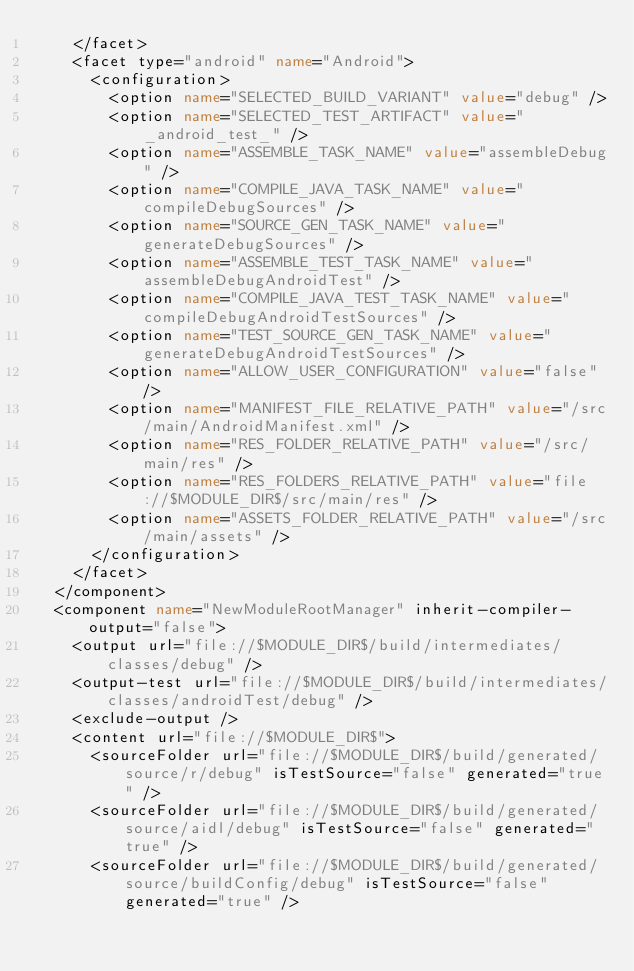<code> <loc_0><loc_0><loc_500><loc_500><_XML_>    </facet>
    <facet type="android" name="Android">
      <configuration>
        <option name="SELECTED_BUILD_VARIANT" value="debug" />
        <option name="SELECTED_TEST_ARTIFACT" value="_android_test_" />
        <option name="ASSEMBLE_TASK_NAME" value="assembleDebug" />
        <option name="COMPILE_JAVA_TASK_NAME" value="compileDebugSources" />
        <option name="SOURCE_GEN_TASK_NAME" value="generateDebugSources" />
        <option name="ASSEMBLE_TEST_TASK_NAME" value="assembleDebugAndroidTest" />
        <option name="COMPILE_JAVA_TEST_TASK_NAME" value="compileDebugAndroidTestSources" />
        <option name="TEST_SOURCE_GEN_TASK_NAME" value="generateDebugAndroidTestSources" />
        <option name="ALLOW_USER_CONFIGURATION" value="false" />
        <option name="MANIFEST_FILE_RELATIVE_PATH" value="/src/main/AndroidManifest.xml" />
        <option name="RES_FOLDER_RELATIVE_PATH" value="/src/main/res" />
        <option name="RES_FOLDERS_RELATIVE_PATH" value="file://$MODULE_DIR$/src/main/res" />
        <option name="ASSETS_FOLDER_RELATIVE_PATH" value="/src/main/assets" />
      </configuration>
    </facet>
  </component>
  <component name="NewModuleRootManager" inherit-compiler-output="false">
    <output url="file://$MODULE_DIR$/build/intermediates/classes/debug" />
    <output-test url="file://$MODULE_DIR$/build/intermediates/classes/androidTest/debug" />
    <exclude-output />
    <content url="file://$MODULE_DIR$">
      <sourceFolder url="file://$MODULE_DIR$/build/generated/source/r/debug" isTestSource="false" generated="true" />
      <sourceFolder url="file://$MODULE_DIR$/build/generated/source/aidl/debug" isTestSource="false" generated="true" />
      <sourceFolder url="file://$MODULE_DIR$/build/generated/source/buildConfig/debug" isTestSource="false" generated="true" /></code> 